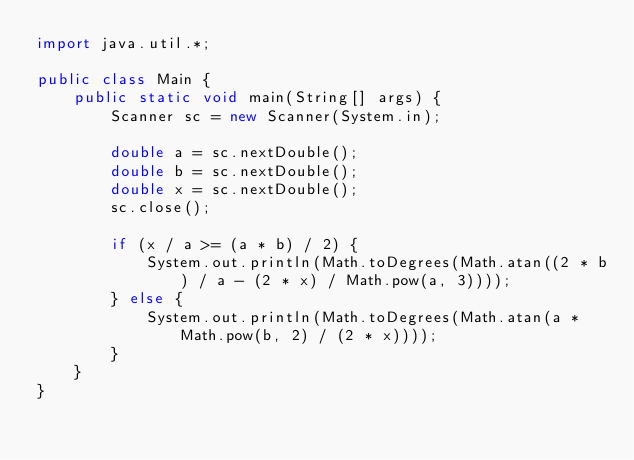<code> <loc_0><loc_0><loc_500><loc_500><_Java_>import java.util.*;

public class Main {
    public static void main(String[] args) {
        Scanner sc = new Scanner(System.in);

        double a = sc.nextDouble();
        double b = sc.nextDouble();
        double x = sc.nextDouble();
        sc.close();

        if (x / a >= (a * b) / 2) {
            System.out.println(Math.toDegrees(Math.atan((2 * b) / a - (2 * x) / Math.pow(a, 3))));
        } else {
            System.out.println(Math.toDegrees(Math.atan(a * Math.pow(b, 2) / (2 * x))));
        }
    }
}</code> 